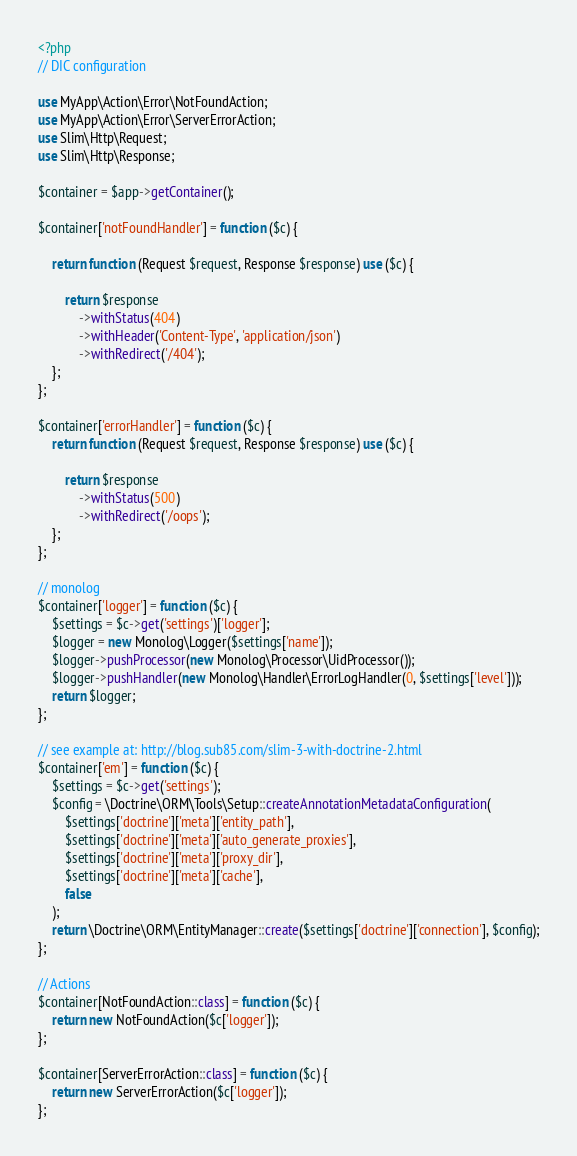Convert code to text. <code><loc_0><loc_0><loc_500><loc_500><_PHP_><?php
// DIC configuration

use MyApp\Action\Error\NotFoundAction;
use MyApp\Action\Error\ServerErrorAction;
use Slim\Http\Request;
use Slim\Http\Response;

$container = $app->getContainer();

$container['notFoundHandler'] = function ($c) {

    return function (Request $request, Response $response) use ($c) {

        return $response
            ->withStatus(404)
            ->withHeader('Content-Type', 'application/json')
            ->withRedirect('/404');
    };
};

$container['errorHandler'] = function ($c) {
    return function (Request $request, Response $response) use ($c) {

        return $response
            ->withStatus(500)
            ->withRedirect('/oops');
    };
};

// monolog
$container['logger'] = function ($c) {
    $settings = $c->get('settings')['logger'];
    $logger = new Monolog\Logger($settings['name']);
    $logger->pushProcessor(new Monolog\Processor\UidProcessor());
    $logger->pushHandler(new Monolog\Handler\ErrorLogHandler(0, $settings['level']));
    return $logger;
};

// see example at: http://blog.sub85.com/slim-3-with-doctrine-2.html
$container['em'] = function ($c) {
    $settings = $c->get('settings');
    $config = \Doctrine\ORM\Tools\Setup::createAnnotationMetadataConfiguration(
        $settings['doctrine']['meta']['entity_path'],
        $settings['doctrine']['meta']['auto_generate_proxies'],
        $settings['doctrine']['meta']['proxy_dir'],
        $settings['doctrine']['meta']['cache'],
        false
    );
    return \Doctrine\ORM\EntityManager::create($settings['doctrine']['connection'], $config);
};

// Actions
$container[NotFoundAction::class] = function ($c) {
    return new NotFoundAction($c['logger']);
};

$container[ServerErrorAction::class] = function ($c) {
    return new ServerErrorAction($c['logger']);
};</code> 